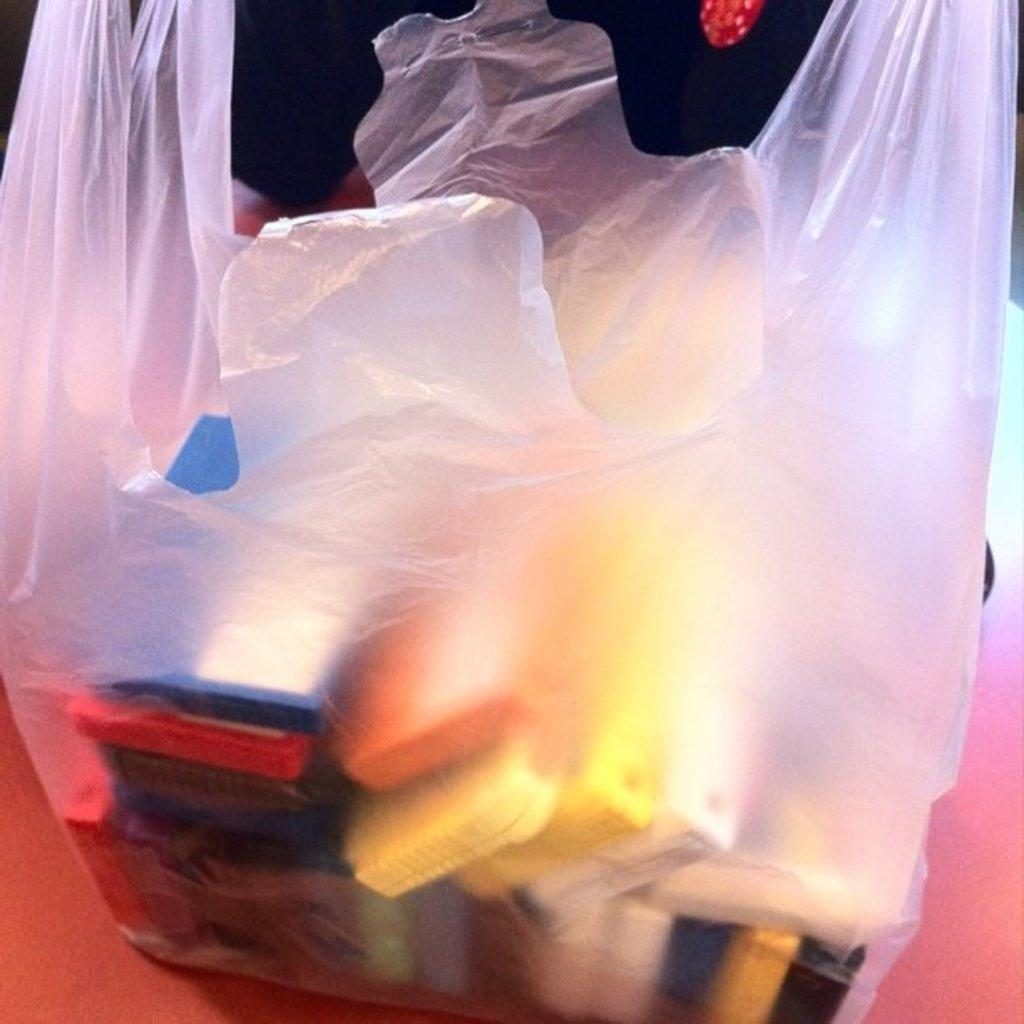What can be observed about the objects in the image? The objects in the image are colorful. How are the colorful objects contained or protected? The objects are in a plastic cover. What is the color of the surface beneath the plastic cover? The plastic cover is on a red surface. What is the color of the background in the image? The background of the image is black. What type of thunder can be heard in the image? There is no sound, including thunder, present in the image. Can you see any bushes or plants in the image? The provided facts do not mention any bushes or plants in the image. 